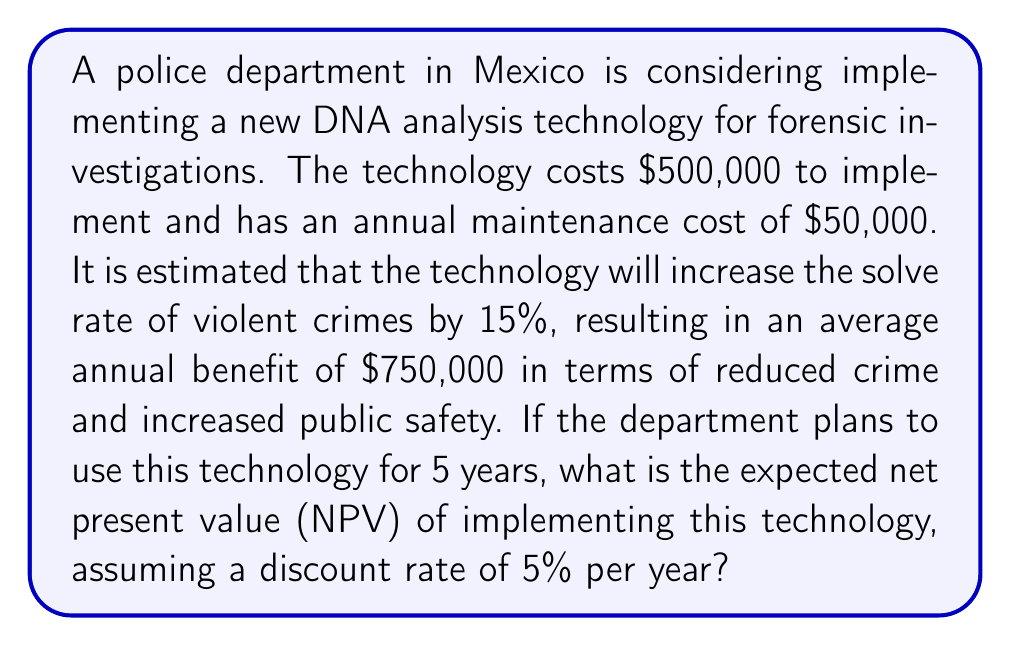Show me your answer to this math problem. To solve this problem, we need to calculate the Net Present Value (NPV) of implementing the new DNA analysis technology. We'll follow these steps:

1. Identify the initial investment and annual cash flows:
   - Initial investment: $500,000
   - Annual benefit: $750,000
   - Annual maintenance cost: $50,000
   - Net annual cash flow: $750,000 - $50,000 = $700,000

2. Calculate the present value of the annual cash flows for 5 years using the NPV formula:

   $$NPV = -C_0 + \sum_{t=1}^{n} \frac{C_t}{(1+r)^t}$$

   Where:
   $C_0$ is the initial investment
   $C_t$ is the net cash flow at time t
   $r$ is the discount rate
   $n$ is the number of periods

3. Plug in the values:

   $$NPV = -500,000 + \frac{700,000}{(1+0.05)^1} + \frac{700,000}{(1+0.05)^2} + \frac{700,000}{(1+0.05)^3} + \frac{700,000}{(1+0.05)^4} + \frac{700,000}{(1+0.05)^5}$$

4. Calculate each term:
   
   $$NPV = -500,000 + 666,666.67 + 634,920.63 + 604,686.32 + 575,891.73 + 548,468.31$$

5. Sum up all terms:

   $$NPV = 2,530,633.66$$

Therefore, the expected Net Present Value of implementing the new DNA analysis technology over 5 years is approximately $2,530,633.66.
Answer: $2,530,633.66 